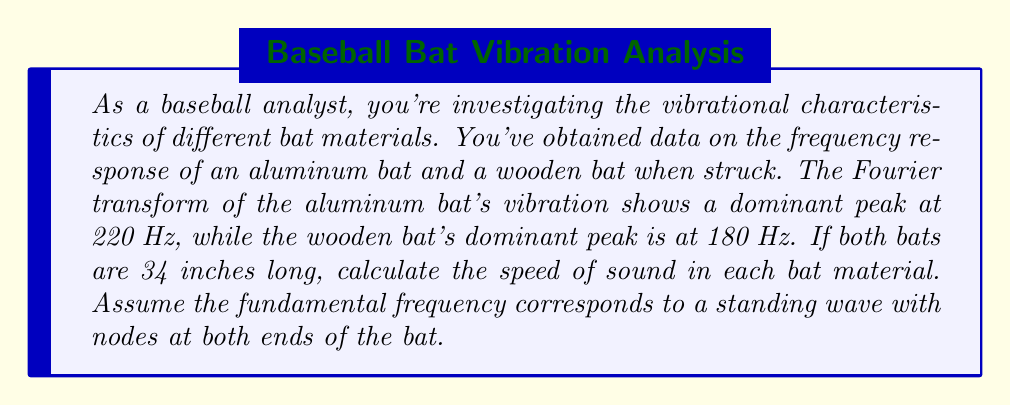Provide a solution to this math problem. To solve this problem, we'll use the relationship between frequency, wavelength, and wave speed, along with the properties of standing waves in a fixed-fixed system (like a bat with both ends as nodes).

1. The wave equation: $v = f\lambda$, where $v$ is wave speed, $f$ is frequency, and $\lambda$ is wavelength.

2. For a fixed-fixed system, the fundamental frequency corresponds to a standing wave with a wavelength twice the length of the object:
   $\lambda = 2L$, where $L$ is the length of the bat.

3. Convert bat length to meters:
   34 inches = 34 * 0.0254 = 0.8636 meters

4. Calculate wavelength:
   $\lambda = 2L = 2 * 0.8636 = 1.7272$ meters

5. For the aluminum bat:
   $v_{Al} = f_{Al} * \lambda = 220 \text{ Hz} * 1.7272 \text{ m} = 380.0 \text{ m/s}$

6. For the wooden bat:
   $v_{wood} = f_{wood} * \lambda = 180 \text{ Hz} * 1.7272 \text{ m} = 310.9 \text{ m/s}$

These calculated speeds represent the speed of sound in each bat material, which is related to the material's elasticity and density.
Answer: The speed of sound in the aluminum bat is approximately 380.0 m/s, and in the wooden bat is approximately 310.9 m/s. 